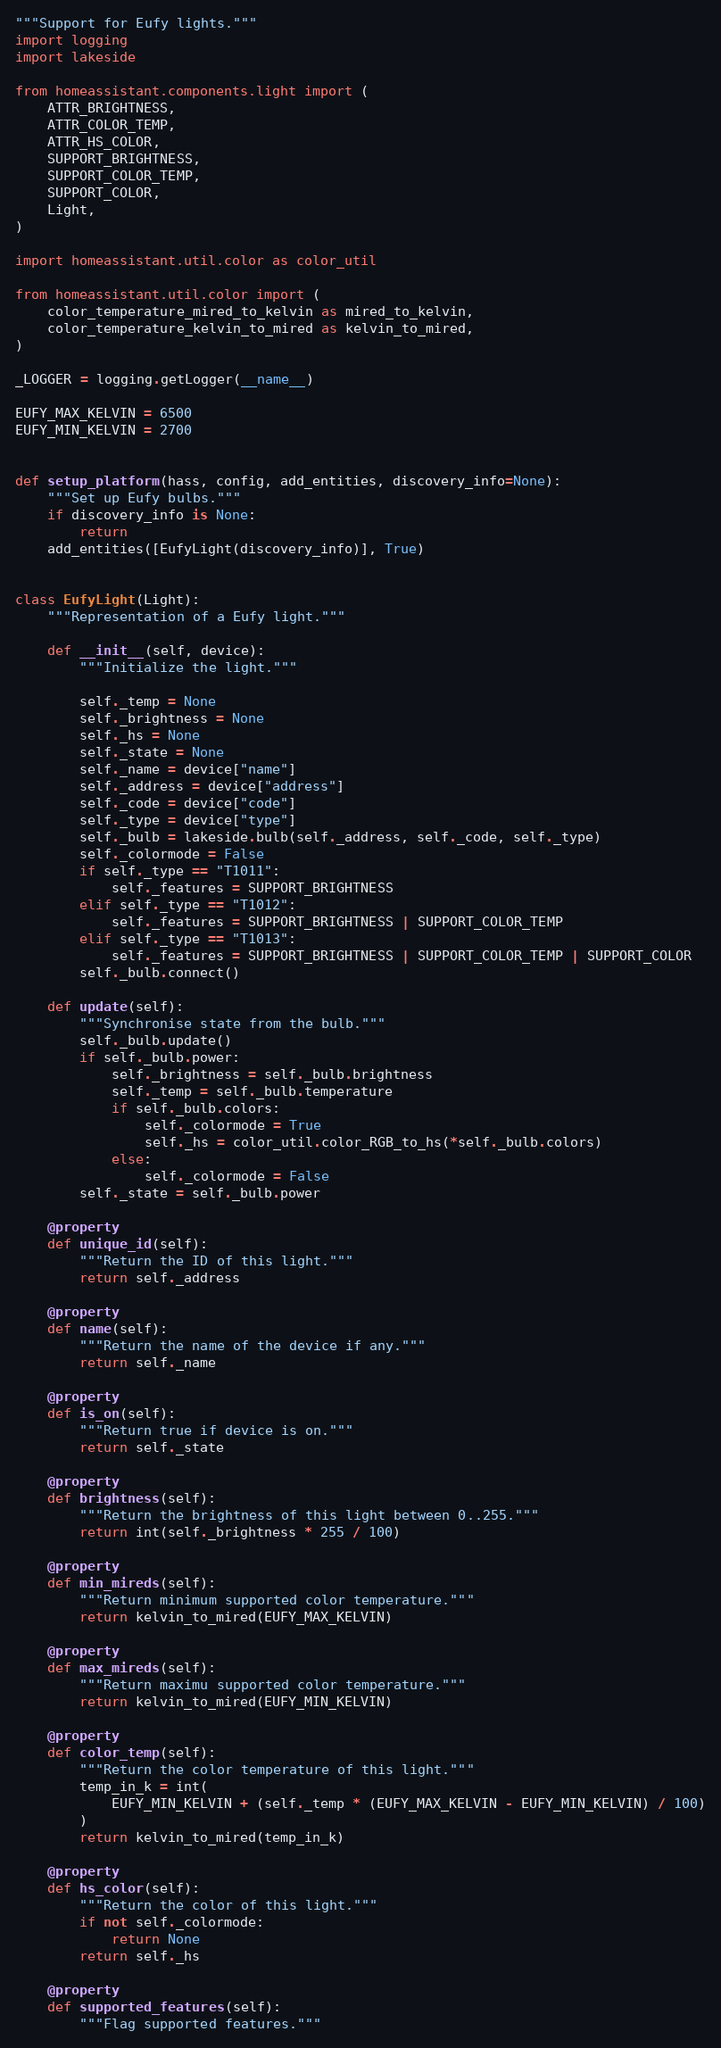Convert code to text. <code><loc_0><loc_0><loc_500><loc_500><_Python_>"""Support for Eufy lights."""
import logging
import lakeside

from homeassistant.components.light import (
    ATTR_BRIGHTNESS,
    ATTR_COLOR_TEMP,
    ATTR_HS_COLOR,
    SUPPORT_BRIGHTNESS,
    SUPPORT_COLOR_TEMP,
    SUPPORT_COLOR,
    Light,
)

import homeassistant.util.color as color_util

from homeassistant.util.color import (
    color_temperature_mired_to_kelvin as mired_to_kelvin,
    color_temperature_kelvin_to_mired as kelvin_to_mired,
)

_LOGGER = logging.getLogger(__name__)

EUFY_MAX_KELVIN = 6500
EUFY_MIN_KELVIN = 2700


def setup_platform(hass, config, add_entities, discovery_info=None):
    """Set up Eufy bulbs."""
    if discovery_info is None:
        return
    add_entities([EufyLight(discovery_info)], True)


class EufyLight(Light):
    """Representation of a Eufy light."""

    def __init__(self, device):
        """Initialize the light."""

        self._temp = None
        self._brightness = None
        self._hs = None
        self._state = None
        self._name = device["name"]
        self._address = device["address"]
        self._code = device["code"]
        self._type = device["type"]
        self._bulb = lakeside.bulb(self._address, self._code, self._type)
        self._colormode = False
        if self._type == "T1011":
            self._features = SUPPORT_BRIGHTNESS
        elif self._type == "T1012":
            self._features = SUPPORT_BRIGHTNESS | SUPPORT_COLOR_TEMP
        elif self._type == "T1013":
            self._features = SUPPORT_BRIGHTNESS | SUPPORT_COLOR_TEMP | SUPPORT_COLOR
        self._bulb.connect()

    def update(self):
        """Synchronise state from the bulb."""
        self._bulb.update()
        if self._bulb.power:
            self._brightness = self._bulb.brightness
            self._temp = self._bulb.temperature
            if self._bulb.colors:
                self._colormode = True
                self._hs = color_util.color_RGB_to_hs(*self._bulb.colors)
            else:
                self._colormode = False
        self._state = self._bulb.power

    @property
    def unique_id(self):
        """Return the ID of this light."""
        return self._address

    @property
    def name(self):
        """Return the name of the device if any."""
        return self._name

    @property
    def is_on(self):
        """Return true if device is on."""
        return self._state

    @property
    def brightness(self):
        """Return the brightness of this light between 0..255."""
        return int(self._brightness * 255 / 100)

    @property
    def min_mireds(self):
        """Return minimum supported color temperature."""
        return kelvin_to_mired(EUFY_MAX_KELVIN)

    @property
    def max_mireds(self):
        """Return maximu supported color temperature."""
        return kelvin_to_mired(EUFY_MIN_KELVIN)

    @property
    def color_temp(self):
        """Return the color temperature of this light."""
        temp_in_k = int(
            EUFY_MIN_KELVIN + (self._temp * (EUFY_MAX_KELVIN - EUFY_MIN_KELVIN) / 100)
        )
        return kelvin_to_mired(temp_in_k)

    @property
    def hs_color(self):
        """Return the color of this light."""
        if not self._colormode:
            return None
        return self._hs

    @property
    def supported_features(self):
        """Flag supported features."""</code> 